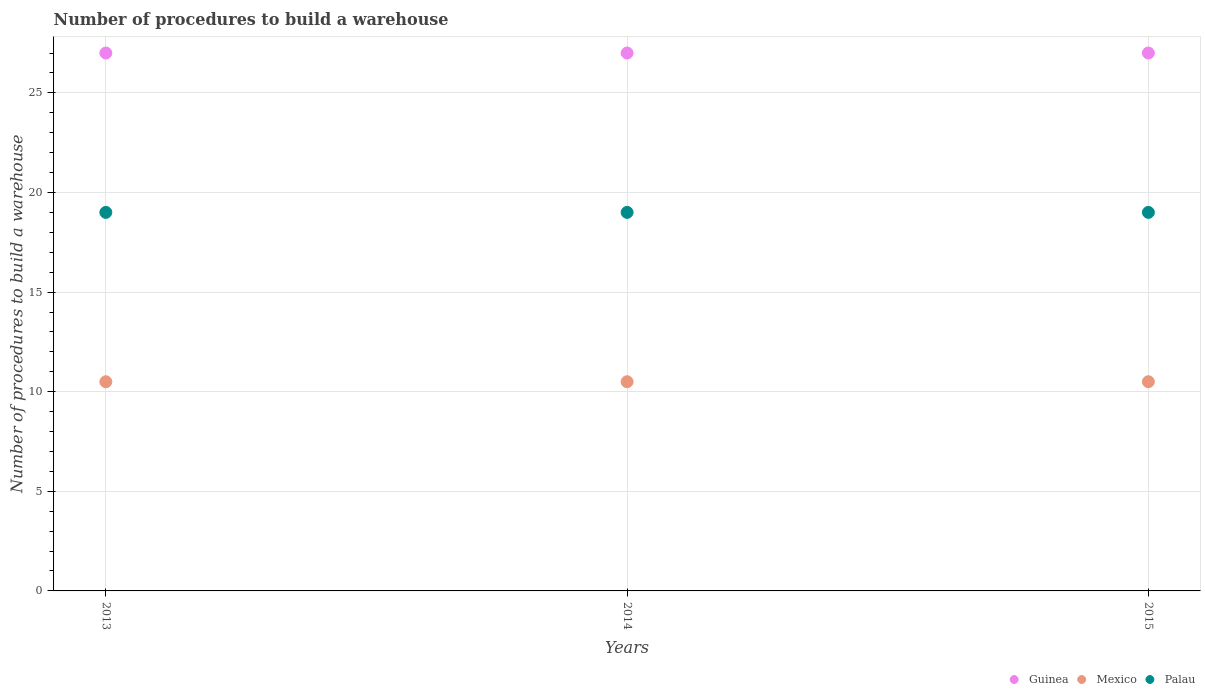How many different coloured dotlines are there?
Provide a succinct answer. 3. What is the number of procedures to build a warehouse in in Guinea in 2014?
Provide a short and direct response. 27. Across all years, what is the maximum number of procedures to build a warehouse in in Mexico?
Make the answer very short. 10.5. In which year was the number of procedures to build a warehouse in in Mexico maximum?
Ensure brevity in your answer.  2013. In which year was the number of procedures to build a warehouse in in Guinea minimum?
Offer a terse response. 2013. What is the total number of procedures to build a warehouse in in Guinea in the graph?
Provide a succinct answer. 81. What is the difference between the number of procedures to build a warehouse in in Palau in 2015 and the number of procedures to build a warehouse in in Guinea in 2013?
Offer a terse response. -8. In the year 2015, what is the difference between the number of procedures to build a warehouse in in Palau and number of procedures to build a warehouse in in Guinea?
Provide a short and direct response. -8. What is the ratio of the number of procedures to build a warehouse in in Palau in 2013 to that in 2014?
Give a very brief answer. 1. Is the difference between the number of procedures to build a warehouse in in Palau in 2013 and 2014 greater than the difference between the number of procedures to build a warehouse in in Guinea in 2013 and 2014?
Make the answer very short. No. What is the difference between the highest and the second highest number of procedures to build a warehouse in in Guinea?
Your answer should be compact. 0. In how many years, is the number of procedures to build a warehouse in in Guinea greater than the average number of procedures to build a warehouse in in Guinea taken over all years?
Ensure brevity in your answer.  0. Is the number of procedures to build a warehouse in in Palau strictly less than the number of procedures to build a warehouse in in Guinea over the years?
Provide a succinct answer. Yes. Does the graph contain any zero values?
Keep it short and to the point. No. Where does the legend appear in the graph?
Keep it short and to the point. Bottom right. How many legend labels are there?
Give a very brief answer. 3. What is the title of the graph?
Your response must be concise. Number of procedures to build a warehouse. Does "Sub-Saharan Africa (all income levels)" appear as one of the legend labels in the graph?
Offer a very short reply. No. What is the label or title of the X-axis?
Make the answer very short. Years. What is the label or title of the Y-axis?
Offer a very short reply. Number of procedures to build a warehouse. What is the Number of procedures to build a warehouse in Guinea in 2013?
Your answer should be compact. 27. What is the Number of procedures to build a warehouse in Mexico in 2013?
Your answer should be very brief. 10.5. What is the Number of procedures to build a warehouse of Guinea in 2014?
Make the answer very short. 27. What is the Number of procedures to build a warehouse in Palau in 2014?
Offer a very short reply. 19. What is the Number of procedures to build a warehouse of Guinea in 2015?
Give a very brief answer. 27. What is the Number of procedures to build a warehouse of Mexico in 2015?
Give a very brief answer. 10.5. Across all years, what is the maximum Number of procedures to build a warehouse in Palau?
Offer a very short reply. 19. Across all years, what is the minimum Number of procedures to build a warehouse in Guinea?
Offer a very short reply. 27. What is the total Number of procedures to build a warehouse of Guinea in the graph?
Give a very brief answer. 81. What is the total Number of procedures to build a warehouse of Mexico in the graph?
Keep it short and to the point. 31.5. What is the difference between the Number of procedures to build a warehouse of Guinea in 2013 and that in 2014?
Your answer should be compact. 0. What is the difference between the Number of procedures to build a warehouse of Mexico in 2013 and that in 2015?
Your answer should be very brief. 0. What is the difference between the Number of procedures to build a warehouse of Palau in 2013 and that in 2015?
Give a very brief answer. 0. What is the difference between the Number of procedures to build a warehouse in Guinea in 2014 and that in 2015?
Offer a very short reply. 0. What is the difference between the Number of procedures to build a warehouse in Mexico in 2013 and the Number of procedures to build a warehouse in Palau in 2014?
Your answer should be compact. -8.5. What is the average Number of procedures to build a warehouse in Palau per year?
Provide a succinct answer. 19. In the year 2014, what is the difference between the Number of procedures to build a warehouse of Guinea and Number of procedures to build a warehouse of Mexico?
Offer a terse response. 16.5. In the year 2014, what is the difference between the Number of procedures to build a warehouse in Guinea and Number of procedures to build a warehouse in Palau?
Your response must be concise. 8. In the year 2014, what is the difference between the Number of procedures to build a warehouse in Mexico and Number of procedures to build a warehouse in Palau?
Your answer should be very brief. -8.5. In the year 2015, what is the difference between the Number of procedures to build a warehouse of Guinea and Number of procedures to build a warehouse of Mexico?
Provide a short and direct response. 16.5. In the year 2015, what is the difference between the Number of procedures to build a warehouse of Guinea and Number of procedures to build a warehouse of Palau?
Give a very brief answer. 8. In the year 2015, what is the difference between the Number of procedures to build a warehouse of Mexico and Number of procedures to build a warehouse of Palau?
Your answer should be compact. -8.5. What is the ratio of the Number of procedures to build a warehouse in Mexico in 2013 to that in 2014?
Ensure brevity in your answer.  1. What is the ratio of the Number of procedures to build a warehouse in Palau in 2013 to that in 2014?
Keep it short and to the point. 1. What is the ratio of the Number of procedures to build a warehouse in Guinea in 2013 to that in 2015?
Your response must be concise. 1. What is the ratio of the Number of procedures to build a warehouse of Mexico in 2013 to that in 2015?
Ensure brevity in your answer.  1. What is the ratio of the Number of procedures to build a warehouse of Palau in 2013 to that in 2015?
Offer a terse response. 1. What is the ratio of the Number of procedures to build a warehouse of Guinea in 2014 to that in 2015?
Give a very brief answer. 1. What is the difference between the highest and the second highest Number of procedures to build a warehouse in Guinea?
Provide a short and direct response. 0. What is the difference between the highest and the second highest Number of procedures to build a warehouse of Mexico?
Your response must be concise. 0. What is the difference between the highest and the lowest Number of procedures to build a warehouse of Palau?
Provide a short and direct response. 0. 